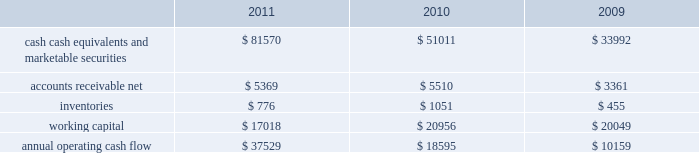35% ( 35 % ) due primarily to certain undistributed foreign earnings for which no u.s .
Taxes are provided because such earnings are intended to be indefinitely reinvested outside the u.s .
As of september 24 , 2011 , the company had deferred tax assets arising from deductible temporary differences , tax losses , and tax credits of $ 3.2 billion , and deferred tax liabilities of $ 9.2 billion .
Management believes it is more likely than not that forecasted income , including income that may be generated as a result of certain tax planning strategies , together with future reversals of existing taxable temporary differences , will be sufficient to fully recover the deferred tax assets .
The company will continue to evaluate the realizability of deferred tax assets quarterly by assessing the need for and amount of a valuation allowance .
The internal revenue service ( the 201cirs 201d ) has completed its field audit of the company 2019s federal income tax returns for the years 2004 through 2006 and proposed certain adjustments .
The company has contested certain of these adjustments through the irs appeals office .
The irs is currently examining the years 2007 through 2009 .
All irs audit issues for years prior to 2004 have been resolved .
In addition , the company is subject to audits by state , local , and foreign tax authorities .
Management believes that adequate provisions have been made for any adjustments that may result from tax examinations .
However , the outcome of tax audits cannot be predicted with certainty .
If any issues addressed in the company 2019s tax audits are resolved in a manner not consistent with management 2019s expectations , the company could be required to adjust its provision for income taxes in the period such resolution occurs .
Liquidity and capital resources the table presents selected financial information and statistics as of and for the three years ended september 24 , 2011 ( in millions ) : .
Cash , cash equivalents and marketable securities increased $ 30.6 billion or 60% ( 60 % ) during 2011 .
The principal components of this net increase was the cash generated by operating activities of $ 37.5 billion , which was partially offset by payments for acquisition of property , plant and equipment of $ 4.3 billion , payments for acquisition of intangible assets of $ 3.2 billion and payments made in connection with business acquisitions , net of cash acquired , of $ 244 million .
The company believes its existing balances of cash , cash equivalents and marketable securities will be sufficient to satisfy its working capital needs , capital asset purchases , outstanding commitments and other liquidity requirements associated with its existing operations over the next 12 months .
The company 2019s marketable securities investment portfolio is invested primarily in highly rated securities and its policy generally limits the amount of credit exposure to any one issuer .
The company 2019s investment policy requires investments to generally be investment grade with the objective of minimizing the potential risk of principal loss .
As of september 24 , 2011 and september 25 , 2010 , $ 54.3 billion and $ 30.8 billion , respectively , of the company 2019s cash , cash equivalents and marketable securities were held by foreign subsidiaries and are generally based in u.s .
Dollar-denominated holdings .
Amounts held by foreign subsidiaries are generally subject to u.s .
Income taxation on repatriation to the u.s .
Capital assets the company 2019s capital expenditures were $ 4.6 billion during 2011 , consisting of approximately $ 614 million for retail store facilities and $ 4.0 billion for other capital expenditures , including product tooling and manufacturing .
What is the percentage change in annual operating cash flow from 2009 to 2010? 
Computations: ((18595 - 10159) / 10159)
Answer: 0.8304. 